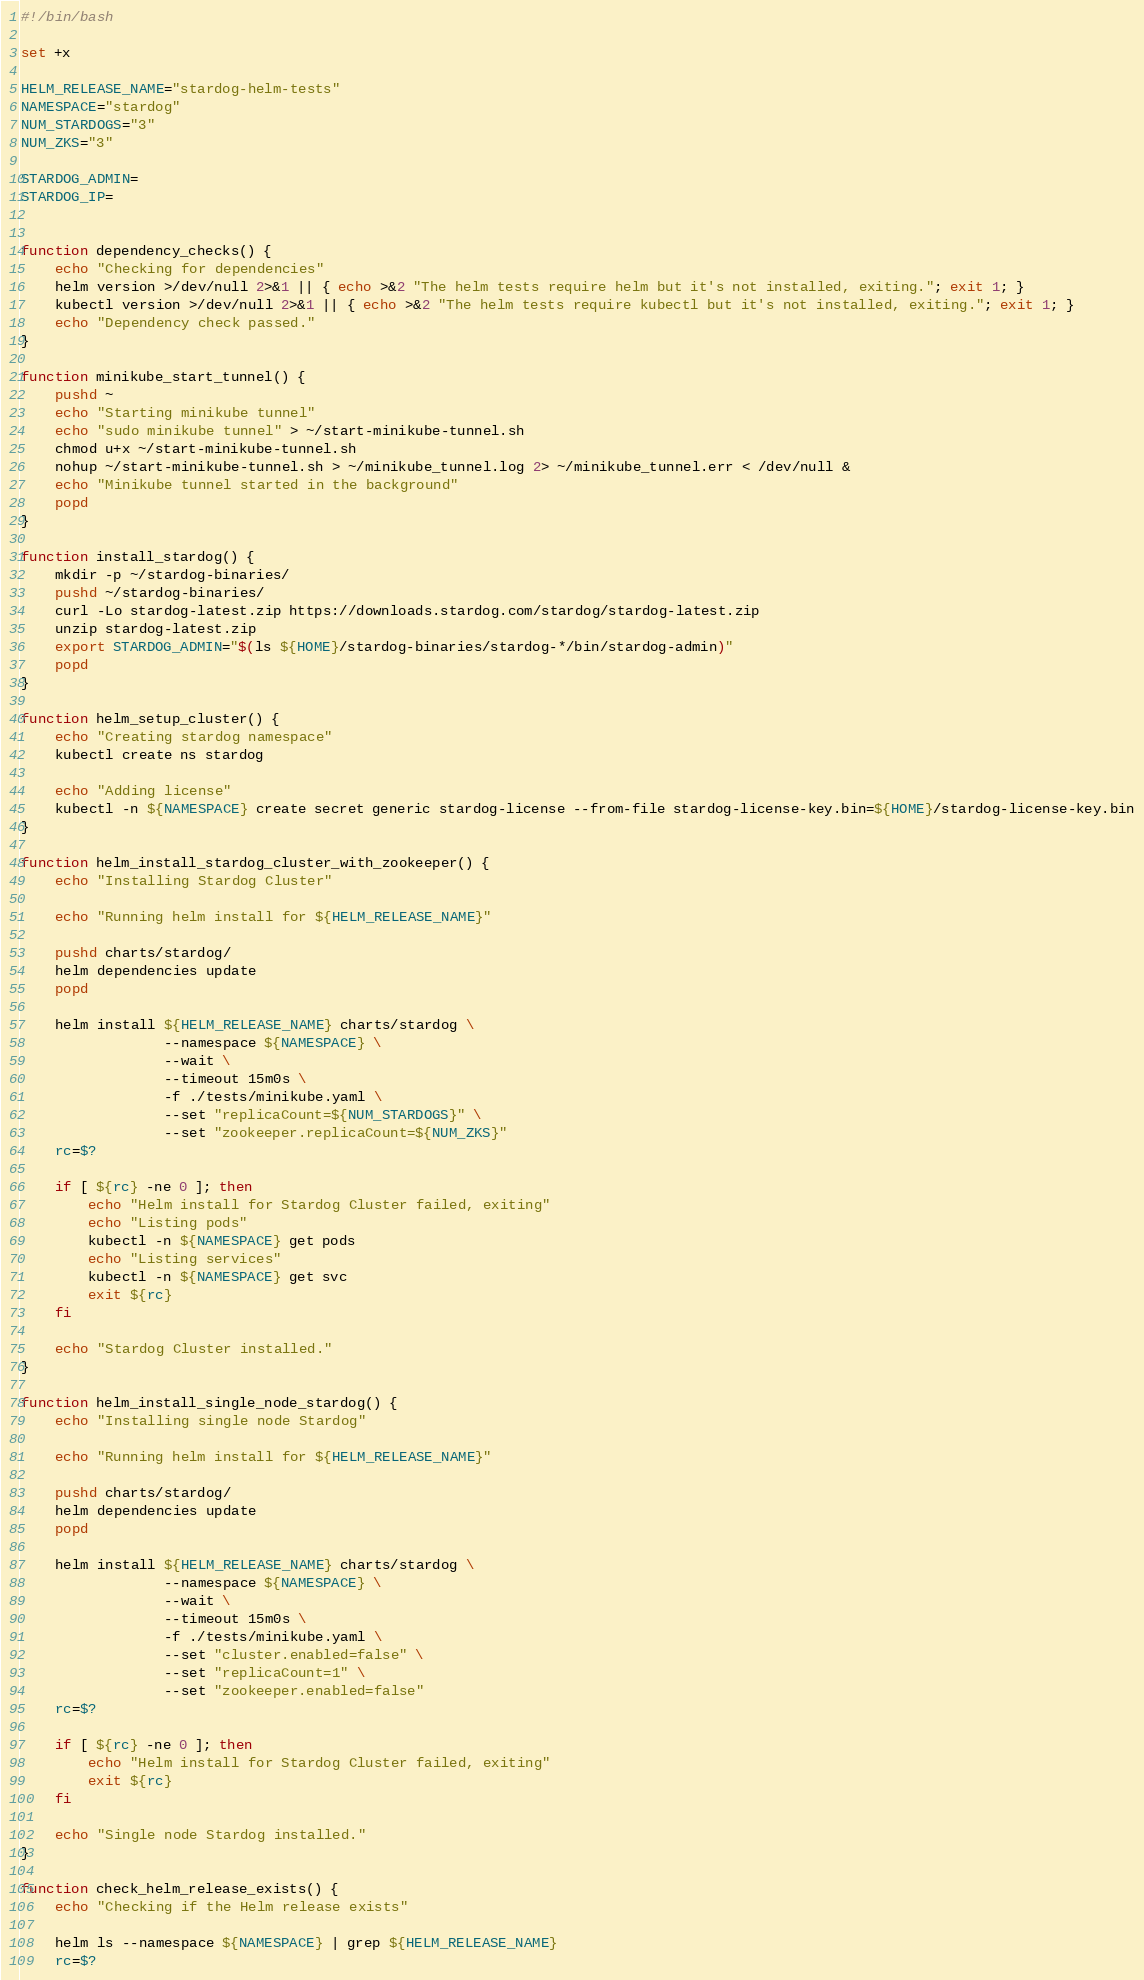Convert code to text. <code><loc_0><loc_0><loc_500><loc_500><_Bash_>#!/bin/bash

set +x

HELM_RELEASE_NAME="stardog-helm-tests"
NAMESPACE="stardog"
NUM_STARDOGS="3"
NUM_ZKS="3"

STARDOG_ADMIN=
STARDOG_IP=


function dependency_checks() {
	echo "Checking for dependencies"
	helm version >/dev/null 2>&1 || { echo >&2 "The helm tests require helm but it's not installed, exiting."; exit 1; }
	kubectl version >/dev/null 2>&1 || { echo >&2 "The helm tests require kubectl but it's not installed, exiting."; exit 1; }
	echo "Dependency check passed."
}

function minikube_start_tunnel() {
	pushd ~
	echo "Starting minikube tunnel"
	echo "sudo minikube tunnel" > ~/start-minikube-tunnel.sh
	chmod u+x ~/start-minikube-tunnel.sh
	nohup ~/start-minikube-tunnel.sh > ~/minikube_tunnel.log 2> ~/minikube_tunnel.err < /dev/null &
	echo "Minikube tunnel started in the background"
	popd
}

function install_stardog() {
	mkdir -p ~/stardog-binaries/
	pushd ~/stardog-binaries/
	curl -Lo stardog-latest.zip https://downloads.stardog.com/stardog/stardog-latest.zip
	unzip stardog-latest.zip
	export STARDOG_ADMIN="$(ls ${HOME}/stardog-binaries/stardog-*/bin/stardog-admin)"
	popd
}

function helm_setup_cluster() {
	echo "Creating stardog namespace"
	kubectl create ns stardog

	echo "Adding license"
	kubectl -n ${NAMESPACE} create secret generic stardog-license --from-file stardog-license-key.bin=${HOME}/stardog-license-key.bin
}

function helm_install_stardog_cluster_with_zookeeper() {
	echo "Installing Stardog Cluster"

	echo "Running helm install for ${HELM_RELEASE_NAME}"

	pushd charts/stardog/
	helm dependencies update
	popd

	helm install ${HELM_RELEASE_NAME} charts/stardog \
	             --namespace ${NAMESPACE} \
	             --wait \
	             --timeout 15m0s \
	             -f ./tests/minikube.yaml \
	             --set "replicaCount=${NUM_STARDOGS}" \
	             --set "zookeeper.replicaCount=${NUM_ZKS}"
	rc=$?

	if [ ${rc} -ne 0 ]; then
		echo "Helm install for Stardog Cluster failed, exiting"
		echo "Listing pods"
		kubectl -n ${NAMESPACE} get pods
		echo "Listing services"
		kubectl -n ${NAMESPACE} get svc
		exit ${rc}
	fi

	echo "Stardog Cluster installed."
}

function helm_install_single_node_stardog() {
	echo "Installing single node Stardog"

	echo "Running helm install for ${HELM_RELEASE_NAME}"

	pushd charts/stardog/
	helm dependencies update
	popd

	helm install ${HELM_RELEASE_NAME} charts/stardog \
	             --namespace ${NAMESPACE} \
	             --wait \
	             --timeout 15m0s \
	             -f ./tests/minikube.yaml \
	             --set "cluster.enabled=false" \
	             --set "replicaCount=1" \
	             --set "zookeeper.enabled=false"
	rc=$?

	if [ ${rc} -ne 0 ]; then
		echo "Helm install for Stardog Cluster failed, exiting"
		exit ${rc}
	fi

	echo "Single node Stardog installed."
}

function check_helm_release_exists() {
	echo "Checking if the Helm release exists"

	helm ls --namespace ${NAMESPACE} | grep ${HELM_RELEASE_NAME}
	rc=$?</code> 